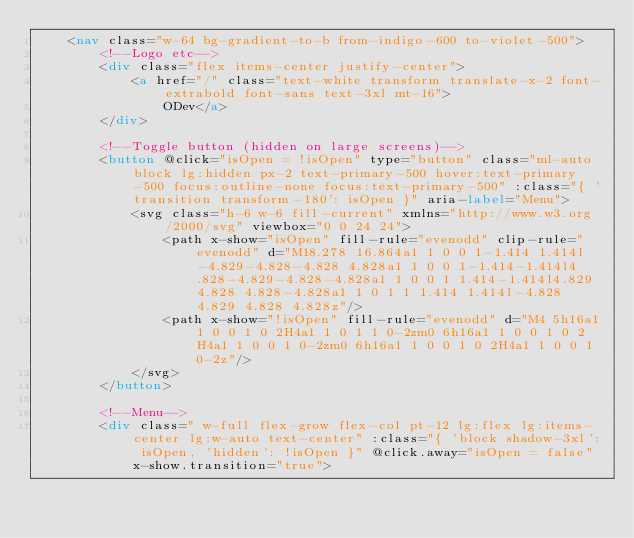Convert code to text. <code><loc_0><loc_0><loc_500><loc_500><_HTML_>    <nav class="w-64 bg-gradient-to-b from-indigo-600 to-violet-500">
        <!--Logo etc-->
        <div class="flex items-center justify-center">
            <a href="/" class="text-white transform translate-x-2 font-extrabold font-sans text-3xl mt-16">
                ODev</a>
        </div>

        <!--Toggle button (hidden on large screens)-->
        <button @click="isOpen = !isOpen" type="button" class="ml-auto block lg:hidden px-2 text-primary-500 hover:text-primary-500 focus:outline-none focus:text-primary-500" :class="{ 'transition transform-180': isOpen }" aria-label="Menu">
            <svg class="h-6 w-6 fill-current" xmlns="http://www.w3.org/2000/svg" viewbox="0 0 24 24">
                <path x-show="isOpen" fill-rule="evenodd" clip-rule="evenodd" d="M18.278 16.864a1 1 0 0 1-1.414 1.414l-4.829-4.828-4.828 4.828a1 1 0 0 1-1.414-1.414l4.828-4.829-4.828-4.828a1 1 0 0 1 1.414-1.414l4.829 4.828 4.828-4.828a1 1 0 1 1 1.414 1.414l-4.828 4.829 4.828 4.828z"/>
                <path x-show="!isOpen" fill-rule="evenodd" d="M4 5h16a1 1 0 0 1 0 2H4a1 1 0 1 1 0-2zm0 6h16a1 1 0 0 1 0 2H4a1 1 0 0 1 0-2zm0 6h16a1 1 0 0 1 0 2H4a1 1 0 0 1 0-2z"/>
            </svg>
        </button>

        <!--Menu-->
        <div class=" w-full flex-grow flex-col pt-12 lg:flex lg:items-center lg:w-auto text-center" :class="{ 'block shadow-3xl': isOpen, 'hidden': !isOpen }" @click.away="isOpen = false" x-show.transition="true">
</code> 